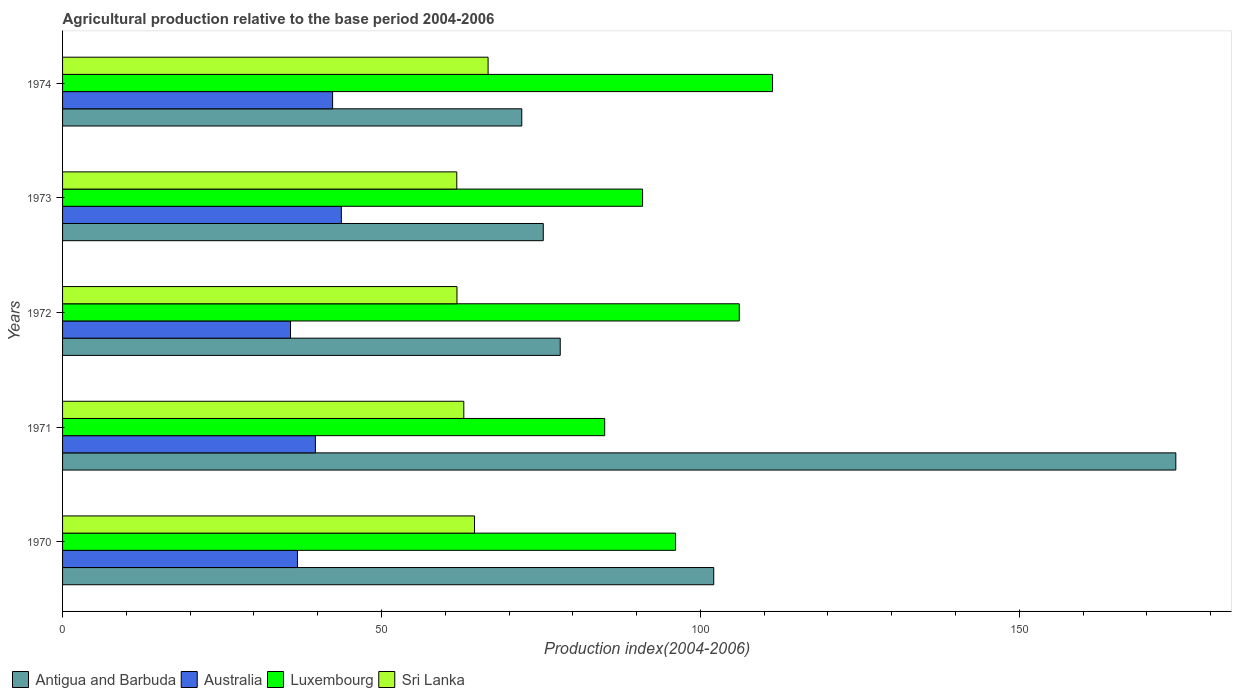How many different coloured bars are there?
Offer a very short reply. 4. How many groups of bars are there?
Ensure brevity in your answer.  5. Are the number of bars on each tick of the Y-axis equal?
Ensure brevity in your answer.  Yes. How many bars are there on the 4th tick from the top?
Provide a succinct answer. 4. What is the agricultural production index in Sri Lanka in 1974?
Offer a very short reply. 66.72. Across all years, what is the maximum agricultural production index in Luxembourg?
Your response must be concise. 111.32. Across all years, what is the minimum agricultural production index in Sri Lanka?
Offer a very short reply. 61.81. In which year was the agricultural production index in Antigua and Barbuda maximum?
Keep it short and to the point. 1971. In which year was the agricultural production index in Australia minimum?
Make the answer very short. 1972. What is the total agricultural production index in Australia in the graph?
Provide a succinct answer. 198.26. What is the difference between the agricultural production index in Antigua and Barbuda in 1972 and that in 1973?
Give a very brief answer. 2.66. What is the difference between the agricultural production index in Antigua and Barbuda in 1973 and the agricultural production index in Luxembourg in 1974?
Offer a very short reply. -35.95. What is the average agricultural production index in Antigua and Barbuda per year?
Your response must be concise. 100.41. In the year 1973, what is the difference between the agricultural production index in Australia and agricultural production index in Luxembourg?
Offer a very short reply. -47.23. In how many years, is the agricultural production index in Australia greater than 110 ?
Provide a short and direct response. 0. What is the ratio of the agricultural production index in Antigua and Barbuda in 1971 to that in 1974?
Keep it short and to the point. 2.42. Is the difference between the agricultural production index in Australia in 1972 and 1973 greater than the difference between the agricultural production index in Luxembourg in 1972 and 1973?
Your answer should be very brief. No. What is the difference between the highest and the second highest agricultural production index in Antigua and Barbuda?
Keep it short and to the point. 72.45. What is the difference between the highest and the lowest agricultural production index in Australia?
Your response must be concise. 7.97. Is it the case that in every year, the sum of the agricultural production index in Sri Lanka and agricultural production index in Australia is greater than the sum of agricultural production index in Antigua and Barbuda and agricultural production index in Luxembourg?
Keep it short and to the point. No. What does the 1st bar from the top in 1972 represents?
Ensure brevity in your answer.  Sri Lanka. What does the 1st bar from the bottom in 1973 represents?
Make the answer very short. Antigua and Barbuda. Is it the case that in every year, the sum of the agricultural production index in Luxembourg and agricultural production index in Antigua and Barbuda is greater than the agricultural production index in Sri Lanka?
Provide a short and direct response. Yes. How many bars are there?
Make the answer very short. 20. How many years are there in the graph?
Offer a very short reply. 5. What is the difference between two consecutive major ticks on the X-axis?
Your answer should be very brief. 50. Are the values on the major ticks of X-axis written in scientific E-notation?
Your answer should be very brief. No. Does the graph contain grids?
Your response must be concise. No. How many legend labels are there?
Make the answer very short. 4. How are the legend labels stacked?
Offer a terse response. Horizontal. What is the title of the graph?
Offer a terse response. Agricultural production relative to the base period 2004-2006. Does "Puerto Rico" appear as one of the legend labels in the graph?
Provide a succinct answer. No. What is the label or title of the X-axis?
Provide a short and direct response. Production index(2004-2006). What is the label or title of the Y-axis?
Make the answer very short. Years. What is the Production index(2004-2006) of Antigua and Barbuda in 1970?
Your response must be concise. 102.1. What is the Production index(2004-2006) in Australia in 1970?
Provide a short and direct response. 36.83. What is the Production index(2004-2006) in Luxembourg in 1970?
Make the answer very short. 96.11. What is the Production index(2004-2006) in Sri Lanka in 1970?
Offer a terse response. 64.59. What is the Production index(2004-2006) in Antigua and Barbuda in 1971?
Provide a succinct answer. 174.55. What is the Production index(2004-2006) in Australia in 1971?
Your response must be concise. 39.64. What is the Production index(2004-2006) of Luxembourg in 1971?
Ensure brevity in your answer.  85. What is the Production index(2004-2006) of Sri Lanka in 1971?
Ensure brevity in your answer.  62.91. What is the Production index(2004-2006) of Antigua and Barbuda in 1972?
Your answer should be very brief. 78.03. What is the Production index(2004-2006) in Australia in 1972?
Keep it short and to the point. 35.74. What is the Production index(2004-2006) of Luxembourg in 1972?
Keep it short and to the point. 106.1. What is the Production index(2004-2006) in Sri Lanka in 1972?
Make the answer very short. 61.84. What is the Production index(2004-2006) of Antigua and Barbuda in 1973?
Make the answer very short. 75.37. What is the Production index(2004-2006) in Australia in 1973?
Make the answer very short. 43.71. What is the Production index(2004-2006) in Luxembourg in 1973?
Your response must be concise. 90.94. What is the Production index(2004-2006) of Sri Lanka in 1973?
Your response must be concise. 61.81. What is the Production index(2004-2006) in Australia in 1974?
Keep it short and to the point. 42.34. What is the Production index(2004-2006) in Luxembourg in 1974?
Provide a succinct answer. 111.32. What is the Production index(2004-2006) in Sri Lanka in 1974?
Offer a terse response. 66.72. Across all years, what is the maximum Production index(2004-2006) of Antigua and Barbuda?
Provide a succinct answer. 174.55. Across all years, what is the maximum Production index(2004-2006) in Australia?
Offer a very short reply. 43.71. Across all years, what is the maximum Production index(2004-2006) of Luxembourg?
Offer a very short reply. 111.32. Across all years, what is the maximum Production index(2004-2006) in Sri Lanka?
Your answer should be compact. 66.72. Across all years, what is the minimum Production index(2004-2006) in Australia?
Your answer should be compact. 35.74. Across all years, what is the minimum Production index(2004-2006) in Luxembourg?
Your answer should be very brief. 85. Across all years, what is the minimum Production index(2004-2006) of Sri Lanka?
Your response must be concise. 61.81. What is the total Production index(2004-2006) of Antigua and Barbuda in the graph?
Your response must be concise. 502.05. What is the total Production index(2004-2006) in Australia in the graph?
Give a very brief answer. 198.26. What is the total Production index(2004-2006) in Luxembourg in the graph?
Ensure brevity in your answer.  489.47. What is the total Production index(2004-2006) in Sri Lanka in the graph?
Your response must be concise. 317.87. What is the difference between the Production index(2004-2006) of Antigua and Barbuda in 1970 and that in 1971?
Provide a short and direct response. -72.45. What is the difference between the Production index(2004-2006) in Australia in 1970 and that in 1971?
Offer a terse response. -2.81. What is the difference between the Production index(2004-2006) of Luxembourg in 1970 and that in 1971?
Keep it short and to the point. 11.11. What is the difference between the Production index(2004-2006) in Sri Lanka in 1970 and that in 1971?
Make the answer very short. 1.68. What is the difference between the Production index(2004-2006) of Antigua and Barbuda in 1970 and that in 1972?
Your answer should be very brief. 24.07. What is the difference between the Production index(2004-2006) of Australia in 1970 and that in 1972?
Make the answer very short. 1.09. What is the difference between the Production index(2004-2006) in Luxembourg in 1970 and that in 1972?
Offer a very short reply. -9.99. What is the difference between the Production index(2004-2006) of Sri Lanka in 1970 and that in 1972?
Give a very brief answer. 2.75. What is the difference between the Production index(2004-2006) of Antigua and Barbuda in 1970 and that in 1973?
Your answer should be compact. 26.73. What is the difference between the Production index(2004-2006) in Australia in 1970 and that in 1973?
Your response must be concise. -6.88. What is the difference between the Production index(2004-2006) of Luxembourg in 1970 and that in 1973?
Keep it short and to the point. 5.17. What is the difference between the Production index(2004-2006) of Sri Lanka in 1970 and that in 1973?
Your answer should be compact. 2.78. What is the difference between the Production index(2004-2006) in Antigua and Barbuda in 1970 and that in 1974?
Your answer should be compact. 30.1. What is the difference between the Production index(2004-2006) in Australia in 1970 and that in 1974?
Your answer should be compact. -5.51. What is the difference between the Production index(2004-2006) in Luxembourg in 1970 and that in 1974?
Your answer should be compact. -15.21. What is the difference between the Production index(2004-2006) in Sri Lanka in 1970 and that in 1974?
Give a very brief answer. -2.13. What is the difference between the Production index(2004-2006) in Antigua and Barbuda in 1971 and that in 1972?
Offer a terse response. 96.52. What is the difference between the Production index(2004-2006) of Australia in 1971 and that in 1972?
Offer a very short reply. 3.9. What is the difference between the Production index(2004-2006) in Luxembourg in 1971 and that in 1972?
Offer a very short reply. -21.1. What is the difference between the Production index(2004-2006) of Sri Lanka in 1971 and that in 1972?
Provide a succinct answer. 1.07. What is the difference between the Production index(2004-2006) of Antigua and Barbuda in 1971 and that in 1973?
Your response must be concise. 99.18. What is the difference between the Production index(2004-2006) in Australia in 1971 and that in 1973?
Give a very brief answer. -4.07. What is the difference between the Production index(2004-2006) in Luxembourg in 1971 and that in 1973?
Keep it short and to the point. -5.94. What is the difference between the Production index(2004-2006) of Antigua and Barbuda in 1971 and that in 1974?
Your answer should be compact. 102.55. What is the difference between the Production index(2004-2006) of Australia in 1971 and that in 1974?
Your answer should be compact. -2.7. What is the difference between the Production index(2004-2006) in Luxembourg in 1971 and that in 1974?
Your answer should be compact. -26.32. What is the difference between the Production index(2004-2006) in Sri Lanka in 1971 and that in 1974?
Give a very brief answer. -3.81. What is the difference between the Production index(2004-2006) in Antigua and Barbuda in 1972 and that in 1973?
Your answer should be very brief. 2.66. What is the difference between the Production index(2004-2006) in Australia in 1972 and that in 1973?
Ensure brevity in your answer.  -7.97. What is the difference between the Production index(2004-2006) in Luxembourg in 1972 and that in 1973?
Ensure brevity in your answer.  15.16. What is the difference between the Production index(2004-2006) in Sri Lanka in 1972 and that in 1973?
Provide a short and direct response. 0.03. What is the difference between the Production index(2004-2006) of Antigua and Barbuda in 1972 and that in 1974?
Ensure brevity in your answer.  6.03. What is the difference between the Production index(2004-2006) in Australia in 1972 and that in 1974?
Give a very brief answer. -6.6. What is the difference between the Production index(2004-2006) of Luxembourg in 1972 and that in 1974?
Provide a short and direct response. -5.22. What is the difference between the Production index(2004-2006) of Sri Lanka in 1972 and that in 1974?
Provide a short and direct response. -4.88. What is the difference between the Production index(2004-2006) in Antigua and Barbuda in 1973 and that in 1974?
Your response must be concise. 3.37. What is the difference between the Production index(2004-2006) in Australia in 1973 and that in 1974?
Offer a terse response. 1.37. What is the difference between the Production index(2004-2006) of Luxembourg in 1973 and that in 1974?
Provide a short and direct response. -20.38. What is the difference between the Production index(2004-2006) of Sri Lanka in 1973 and that in 1974?
Make the answer very short. -4.91. What is the difference between the Production index(2004-2006) of Antigua and Barbuda in 1970 and the Production index(2004-2006) of Australia in 1971?
Your answer should be compact. 62.46. What is the difference between the Production index(2004-2006) of Antigua and Barbuda in 1970 and the Production index(2004-2006) of Luxembourg in 1971?
Keep it short and to the point. 17.1. What is the difference between the Production index(2004-2006) of Antigua and Barbuda in 1970 and the Production index(2004-2006) of Sri Lanka in 1971?
Your answer should be compact. 39.19. What is the difference between the Production index(2004-2006) in Australia in 1970 and the Production index(2004-2006) in Luxembourg in 1971?
Ensure brevity in your answer.  -48.17. What is the difference between the Production index(2004-2006) in Australia in 1970 and the Production index(2004-2006) in Sri Lanka in 1971?
Offer a very short reply. -26.08. What is the difference between the Production index(2004-2006) in Luxembourg in 1970 and the Production index(2004-2006) in Sri Lanka in 1971?
Give a very brief answer. 33.2. What is the difference between the Production index(2004-2006) of Antigua and Barbuda in 1970 and the Production index(2004-2006) of Australia in 1972?
Your response must be concise. 66.36. What is the difference between the Production index(2004-2006) in Antigua and Barbuda in 1970 and the Production index(2004-2006) in Sri Lanka in 1972?
Offer a very short reply. 40.26. What is the difference between the Production index(2004-2006) of Australia in 1970 and the Production index(2004-2006) of Luxembourg in 1972?
Make the answer very short. -69.27. What is the difference between the Production index(2004-2006) of Australia in 1970 and the Production index(2004-2006) of Sri Lanka in 1972?
Offer a very short reply. -25.01. What is the difference between the Production index(2004-2006) of Luxembourg in 1970 and the Production index(2004-2006) of Sri Lanka in 1972?
Provide a succinct answer. 34.27. What is the difference between the Production index(2004-2006) in Antigua and Barbuda in 1970 and the Production index(2004-2006) in Australia in 1973?
Make the answer very short. 58.39. What is the difference between the Production index(2004-2006) in Antigua and Barbuda in 1970 and the Production index(2004-2006) in Luxembourg in 1973?
Your answer should be very brief. 11.16. What is the difference between the Production index(2004-2006) of Antigua and Barbuda in 1970 and the Production index(2004-2006) of Sri Lanka in 1973?
Make the answer very short. 40.29. What is the difference between the Production index(2004-2006) in Australia in 1970 and the Production index(2004-2006) in Luxembourg in 1973?
Keep it short and to the point. -54.11. What is the difference between the Production index(2004-2006) of Australia in 1970 and the Production index(2004-2006) of Sri Lanka in 1973?
Your response must be concise. -24.98. What is the difference between the Production index(2004-2006) of Luxembourg in 1970 and the Production index(2004-2006) of Sri Lanka in 1973?
Keep it short and to the point. 34.3. What is the difference between the Production index(2004-2006) in Antigua and Barbuda in 1970 and the Production index(2004-2006) in Australia in 1974?
Offer a very short reply. 59.76. What is the difference between the Production index(2004-2006) in Antigua and Barbuda in 1970 and the Production index(2004-2006) in Luxembourg in 1974?
Provide a succinct answer. -9.22. What is the difference between the Production index(2004-2006) in Antigua and Barbuda in 1970 and the Production index(2004-2006) in Sri Lanka in 1974?
Offer a terse response. 35.38. What is the difference between the Production index(2004-2006) in Australia in 1970 and the Production index(2004-2006) in Luxembourg in 1974?
Offer a terse response. -74.49. What is the difference between the Production index(2004-2006) of Australia in 1970 and the Production index(2004-2006) of Sri Lanka in 1974?
Keep it short and to the point. -29.89. What is the difference between the Production index(2004-2006) in Luxembourg in 1970 and the Production index(2004-2006) in Sri Lanka in 1974?
Offer a very short reply. 29.39. What is the difference between the Production index(2004-2006) of Antigua and Barbuda in 1971 and the Production index(2004-2006) of Australia in 1972?
Ensure brevity in your answer.  138.81. What is the difference between the Production index(2004-2006) of Antigua and Barbuda in 1971 and the Production index(2004-2006) of Luxembourg in 1972?
Your answer should be very brief. 68.45. What is the difference between the Production index(2004-2006) of Antigua and Barbuda in 1971 and the Production index(2004-2006) of Sri Lanka in 1972?
Provide a succinct answer. 112.71. What is the difference between the Production index(2004-2006) in Australia in 1971 and the Production index(2004-2006) in Luxembourg in 1972?
Make the answer very short. -66.46. What is the difference between the Production index(2004-2006) in Australia in 1971 and the Production index(2004-2006) in Sri Lanka in 1972?
Make the answer very short. -22.2. What is the difference between the Production index(2004-2006) in Luxembourg in 1971 and the Production index(2004-2006) in Sri Lanka in 1972?
Provide a succinct answer. 23.16. What is the difference between the Production index(2004-2006) in Antigua and Barbuda in 1971 and the Production index(2004-2006) in Australia in 1973?
Ensure brevity in your answer.  130.84. What is the difference between the Production index(2004-2006) in Antigua and Barbuda in 1971 and the Production index(2004-2006) in Luxembourg in 1973?
Make the answer very short. 83.61. What is the difference between the Production index(2004-2006) of Antigua and Barbuda in 1971 and the Production index(2004-2006) of Sri Lanka in 1973?
Provide a succinct answer. 112.74. What is the difference between the Production index(2004-2006) of Australia in 1971 and the Production index(2004-2006) of Luxembourg in 1973?
Your response must be concise. -51.3. What is the difference between the Production index(2004-2006) in Australia in 1971 and the Production index(2004-2006) in Sri Lanka in 1973?
Keep it short and to the point. -22.17. What is the difference between the Production index(2004-2006) in Luxembourg in 1971 and the Production index(2004-2006) in Sri Lanka in 1973?
Offer a very short reply. 23.19. What is the difference between the Production index(2004-2006) in Antigua and Barbuda in 1971 and the Production index(2004-2006) in Australia in 1974?
Provide a short and direct response. 132.21. What is the difference between the Production index(2004-2006) in Antigua and Barbuda in 1971 and the Production index(2004-2006) in Luxembourg in 1974?
Ensure brevity in your answer.  63.23. What is the difference between the Production index(2004-2006) in Antigua and Barbuda in 1971 and the Production index(2004-2006) in Sri Lanka in 1974?
Your answer should be compact. 107.83. What is the difference between the Production index(2004-2006) in Australia in 1971 and the Production index(2004-2006) in Luxembourg in 1974?
Your answer should be very brief. -71.68. What is the difference between the Production index(2004-2006) in Australia in 1971 and the Production index(2004-2006) in Sri Lanka in 1974?
Offer a very short reply. -27.08. What is the difference between the Production index(2004-2006) of Luxembourg in 1971 and the Production index(2004-2006) of Sri Lanka in 1974?
Offer a very short reply. 18.28. What is the difference between the Production index(2004-2006) in Antigua and Barbuda in 1972 and the Production index(2004-2006) in Australia in 1973?
Your response must be concise. 34.32. What is the difference between the Production index(2004-2006) in Antigua and Barbuda in 1972 and the Production index(2004-2006) in Luxembourg in 1973?
Make the answer very short. -12.91. What is the difference between the Production index(2004-2006) in Antigua and Barbuda in 1972 and the Production index(2004-2006) in Sri Lanka in 1973?
Offer a very short reply. 16.22. What is the difference between the Production index(2004-2006) in Australia in 1972 and the Production index(2004-2006) in Luxembourg in 1973?
Provide a short and direct response. -55.2. What is the difference between the Production index(2004-2006) of Australia in 1972 and the Production index(2004-2006) of Sri Lanka in 1973?
Provide a succinct answer. -26.07. What is the difference between the Production index(2004-2006) of Luxembourg in 1972 and the Production index(2004-2006) of Sri Lanka in 1973?
Your response must be concise. 44.29. What is the difference between the Production index(2004-2006) in Antigua and Barbuda in 1972 and the Production index(2004-2006) in Australia in 1974?
Your answer should be very brief. 35.69. What is the difference between the Production index(2004-2006) of Antigua and Barbuda in 1972 and the Production index(2004-2006) of Luxembourg in 1974?
Your answer should be very brief. -33.29. What is the difference between the Production index(2004-2006) of Antigua and Barbuda in 1972 and the Production index(2004-2006) of Sri Lanka in 1974?
Provide a short and direct response. 11.31. What is the difference between the Production index(2004-2006) in Australia in 1972 and the Production index(2004-2006) in Luxembourg in 1974?
Your answer should be compact. -75.58. What is the difference between the Production index(2004-2006) in Australia in 1972 and the Production index(2004-2006) in Sri Lanka in 1974?
Ensure brevity in your answer.  -30.98. What is the difference between the Production index(2004-2006) of Luxembourg in 1972 and the Production index(2004-2006) of Sri Lanka in 1974?
Your answer should be compact. 39.38. What is the difference between the Production index(2004-2006) in Antigua and Barbuda in 1973 and the Production index(2004-2006) in Australia in 1974?
Offer a very short reply. 33.03. What is the difference between the Production index(2004-2006) in Antigua and Barbuda in 1973 and the Production index(2004-2006) in Luxembourg in 1974?
Your answer should be very brief. -35.95. What is the difference between the Production index(2004-2006) in Antigua and Barbuda in 1973 and the Production index(2004-2006) in Sri Lanka in 1974?
Your answer should be very brief. 8.65. What is the difference between the Production index(2004-2006) of Australia in 1973 and the Production index(2004-2006) of Luxembourg in 1974?
Offer a very short reply. -67.61. What is the difference between the Production index(2004-2006) in Australia in 1973 and the Production index(2004-2006) in Sri Lanka in 1974?
Provide a short and direct response. -23.01. What is the difference between the Production index(2004-2006) in Luxembourg in 1973 and the Production index(2004-2006) in Sri Lanka in 1974?
Give a very brief answer. 24.22. What is the average Production index(2004-2006) in Antigua and Barbuda per year?
Give a very brief answer. 100.41. What is the average Production index(2004-2006) in Australia per year?
Keep it short and to the point. 39.65. What is the average Production index(2004-2006) of Luxembourg per year?
Your answer should be very brief. 97.89. What is the average Production index(2004-2006) in Sri Lanka per year?
Keep it short and to the point. 63.57. In the year 1970, what is the difference between the Production index(2004-2006) in Antigua and Barbuda and Production index(2004-2006) in Australia?
Keep it short and to the point. 65.27. In the year 1970, what is the difference between the Production index(2004-2006) in Antigua and Barbuda and Production index(2004-2006) in Luxembourg?
Offer a very short reply. 5.99. In the year 1970, what is the difference between the Production index(2004-2006) of Antigua and Barbuda and Production index(2004-2006) of Sri Lanka?
Provide a short and direct response. 37.51. In the year 1970, what is the difference between the Production index(2004-2006) in Australia and Production index(2004-2006) in Luxembourg?
Your response must be concise. -59.28. In the year 1970, what is the difference between the Production index(2004-2006) in Australia and Production index(2004-2006) in Sri Lanka?
Offer a terse response. -27.76. In the year 1970, what is the difference between the Production index(2004-2006) of Luxembourg and Production index(2004-2006) of Sri Lanka?
Offer a terse response. 31.52. In the year 1971, what is the difference between the Production index(2004-2006) in Antigua and Barbuda and Production index(2004-2006) in Australia?
Your response must be concise. 134.91. In the year 1971, what is the difference between the Production index(2004-2006) of Antigua and Barbuda and Production index(2004-2006) of Luxembourg?
Your answer should be compact. 89.55. In the year 1971, what is the difference between the Production index(2004-2006) in Antigua and Barbuda and Production index(2004-2006) in Sri Lanka?
Offer a very short reply. 111.64. In the year 1971, what is the difference between the Production index(2004-2006) of Australia and Production index(2004-2006) of Luxembourg?
Provide a succinct answer. -45.36. In the year 1971, what is the difference between the Production index(2004-2006) in Australia and Production index(2004-2006) in Sri Lanka?
Give a very brief answer. -23.27. In the year 1971, what is the difference between the Production index(2004-2006) in Luxembourg and Production index(2004-2006) in Sri Lanka?
Your response must be concise. 22.09. In the year 1972, what is the difference between the Production index(2004-2006) in Antigua and Barbuda and Production index(2004-2006) in Australia?
Make the answer very short. 42.29. In the year 1972, what is the difference between the Production index(2004-2006) of Antigua and Barbuda and Production index(2004-2006) of Luxembourg?
Keep it short and to the point. -28.07. In the year 1972, what is the difference between the Production index(2004-2006) of Antigua and Barbuda and Production index(2004-2006) of Sri Lanka?
Keep it short and to the point. 16.19. In the year 1972, what is the difference between the Production index(2004-2006) of Australia and Production index(2004-2006) of Luxembourg?
Provide a succinct answer. -70.36. In the year 1972, what is the difference between the Production index(2004-2006) in Australia and Production index(2004-2006) in Sri Lanka?
Offer a terse response. -26.1. In the year 1972, what is the difference between the Production index(2004-2006) of Luxembourg and Production index(2004-2006) of Sri Lanka?
Your response must be concise. 44.26. In the year 1973, what is the difference between the Production index(2004-2006) of Antigua and Barbuda and Production index(2004-2006) of Australia?
Make the answer very short. 31.66. In the year 1973, what is the difference between the Production index(2004-2006) of Antigua and Barbuda and Production index(2004-2006) of Luxembourg?
Provide a short and direct response. -15.57. In the year 1973, what is the difference between the Production index(2004-2006) of Antigua and Barbuda and Production index(2004-2006) of Sri Lanka?
Provide a short and direct response. 13.56. In the year 1973, what is the difference between the Production index(2004-2006) of Australia and Production index(2004-2006) of Luxembourg?
Ensure brevity in your answer.  -47.23. In the year 1973, what is the difference between the Production index(2004-2006) of Australia and Production index(2004-2006) of Sri Lanka?
Offer a very short reply. -18.1. In the year 1973, what is the difference between the Production index(2004-2006) in Luxembourg and Production index(2004-2006) in Sri Lanka?
Offer a terse response. 29.13. In the year 1974, what is the difference between the Production index(2004-2006) of Antigua and Barbuda and Production index(2004-2006) of Australia?
Keep it short and to the point. 29.66. In the year 1974, what is the difference between the Production index(2004-2006) in Antigua and Barbuda and Production index(2004-2006) in Luxembourg?
Your answer should be compact. -39.32. In the year 1974, what is the difference between the Production index(2004-2006) of Antigua and Barbuda and Production index(2004-2006) of Sri Lanka?
Give a very brief answer. 5.28. In the year 1974, what is the difference between the Production index(2004-2006) in Australia and Production index(2004-2006) in Luxembourg?
Your response must be concise. -68.98. In the year 1974, what is the difference between the Production index(2004-2006) of Australia and Production index(2004-2006) of Sri Lanka?
Your answer should be very brief. -24.38. In the year 1974, what is the difference between the Production index(2004-2006) in Luxembourg and Production index(2004-2006) in Sri Lanka?
Provide a short and direct response. 44.6. What is the ratio of the Production index(2004-2006) of Antigua and Barbuda in 1970 to that in 1971?
Offer a very short reply. 0.58. What is the ratio of the Production index(2004-2006) of Australia in 1970 to that in 1971?
Offer a very short reply. 0.93. What is the ratio of the Production index(2004-2006) in Luxembourg in 1970 to that in 1971?
Your response must be concise. 1.13. What is the ratio of the Production index(2004-2006) of Sri Lanka in 1970 to that in 1971?
Keep it short and to the point. 1.03. What is the ratio of the Production index(2004-2006) in Antigua and Barbuda in 1970 to that in 1972?
Keep it short and to the point. 1.31. What is the ratio of the Production index(2004-2006) of Australia in 1970 to that in 1972?
Make the answer very short. 1.03. What is the ratio of the Production index(2004-2006) in Luxembourg in 1970 to that in 1972?
Your answer should be compact. 0.91. What is the ratio of the Production index(2004-2006) in Sri Lanka in 1970 to that in 1972?
Make the answer very short. 1.04. What is the ratio of the Production index(2004-2006) of Antigua and Barbuda in 1970 to that in 1973?
Offer a terse response. 1.35. What is the ratio of the Production index(2004-2006) of Australia in 1970 to that in 1973?
Ensure brevity in your answer.  0.84. What is the ratio of the Production index(2004-2006) in Luxembourg in 1970 to that in 1973?
Ensure brevity in your answer.  1.06. What is the ratio of the Production index(2004-2006) of Sri Lanka in 1970 to that in 1973?
Offer a very short reply. 1.04. What is the ratio of the Production index(2004-2006) of Antigua and Barbuda in 1970 to that in 1974?
Offer a terse response. 1.42. What is the ratio of the Production index(2004-2006) of Australia in 1970 to that in 1974?
Provide a short and direct response. 0.87. What is the ratio of the Production index(2004-2006) in Luxembourg in 1970 to that in 1974?
Provide a succinct answer. 0.86. What is the ratio of the Production index(2004-2006) in Sri Lanka in 1970 to that in 1974?
Ensure brevity in your answer.  0.97. What is the ratio of the Production index(2004-2006) in Antigua and Barbuda in 1971 to that in 1972?
Ensure brevity in your answer.  2.24. What is the ratio of the Production index(2004-2006) of Australia in 1971 to that in 1972?
Provide a succinct answer. 1.11. What is the ratio of the Production index(2004-2006) of Luxembourg in 1971 to that in 1972?
Ensure brevity in your answer.  0.8. What is the ratio of the Production index(2004-2006) of Sri Lanka in 1971 to that in 1972?
Offer a very short reply. 1.02. What is the ratio of the Production index(2004-2006) of Antigua and Barbuda in 1971 to that in 1973?
Your response must be concise. 2.32. What is the ratio of the Production index(2004-2006) in Australia in 1971 to that in 1973?
Make the answer very short. 0.91. What is the ratio of the Production index(2004-2006) of Luxembourg in 1971 to that in 1973?
Ensure brevity in your answer.  0.93. What is the ratio of the Production index(2004-2006) of Sri Lanka in 1971 to that in 1973?
Your answer should be compact. 1.02. What is the ratio of the Production index(2004-2006) in Antigua and Barbuda in 1971 to that in 1974?
Provide a succinct answer. 2.42. What is the ratio of the Production index(2004-2006) in Australia in 1971 to that in 1974?
Offer a very short reply. 0.94. What is the ratio of the Production index(2004-2006) of Luxembourg in 1971 to that in 1974?
Give a very brief answer. 0.76. What is the ratio of the Production index(2004-2006) of Sri Lanka in 1971 to that in 1974?
Offer a very short reply. 0.94. What is the ratio of the Production index(2004-2006) of Antigua and Barbuda in 1972 to that in 1973?
Your answer should be very brief. 1.04. What is the ratio of the Production index(2004-2006) in Australia in 1972 to that in 1973?
Provide a short and direct response. 0.82. What is the ratio of the Production index(2004-2006) of Luxembourg in 1972 to that in 1973?
Keep it short and to the point. 1.17. What is the ratio of the Production index(2004-2006) in Sri Lanka in 1972 to that in 1973?
Provide a succinct answer. 1. What is the ratio of the Production index(2004-2006) in Antigua and Barbuda in 1972 to that in 1974?
Give a very brief answer. 1.08. What is the ratio of the Production index(2004-2006) of Australia in 1972 to that in 1974?
Provide a short and direct response. 0.84. What is the ratio of the Production index(2004-2006) in Luxembourg in 1972 to that in 1974?
Make the answer very short. 0.95. What is the ratio of the Production index(2004-2006) in Sri Lanka in 1972 to that in 1974?
Offer a terse response. 0.93. What is the ratio of the Production index(2004-2006) in Antigua and Barbuda in 1973 to that in 1974?
Provide a short and direct response. 1.05. What is the ratio of the Production index(2004-2006) in Australia in 1973 to that in 1974?
Your response must be concise. 1.03. What is the ratio of the Production index(2004-2006) in Luxembourg in 1973 to that in 1974?
Provide a short and direct response. 0.82. What is the ratio of the Production index(2004-2006) of Sri Lanka in 1973 to that in 1974?
Ensure brevity in your answer.  0.93. What is the difference between the highest and the second highest Production index(2004-2006) in Antigua and Barbuda?
Give a very brief answer. 72.45. What is the difference between the highest and the second highest Production index(2004-2006) in Australia?
Make the answer very short. 1.37. What is the difference between the highest and the second highest Production index(2004-2006) of Luxembourg?
Offer a terse response. 5.22. What is the difference between the highest and the second highest Production index(2004-2006) in Sri Lanka?
Give a very brief answer. 2.13. What is the difference between the highest and the lowest Production index(2004-2006) in Antigua and Barbuda?
Your response must be concise. 102.55. What is the difference between the highest and the lowest Production index(2004-2006) of Australia?
Make the answer very short. 7.97. What is the difference between the highest and the lowest Production index(2004-2006) of Luxembourg?
Offer a very short reply. 26.32. What is the difference between the highest and the lowest Production index(2004-2006) of Sri Lanka?
Provide a short and direct response. 4.91. 